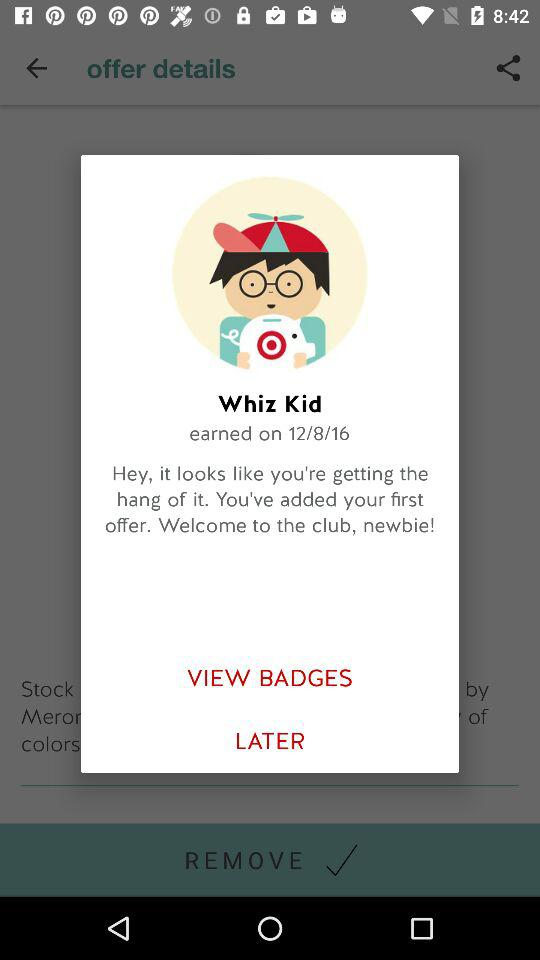What is the badge earned date? The badge earned date is 12/8/16. 